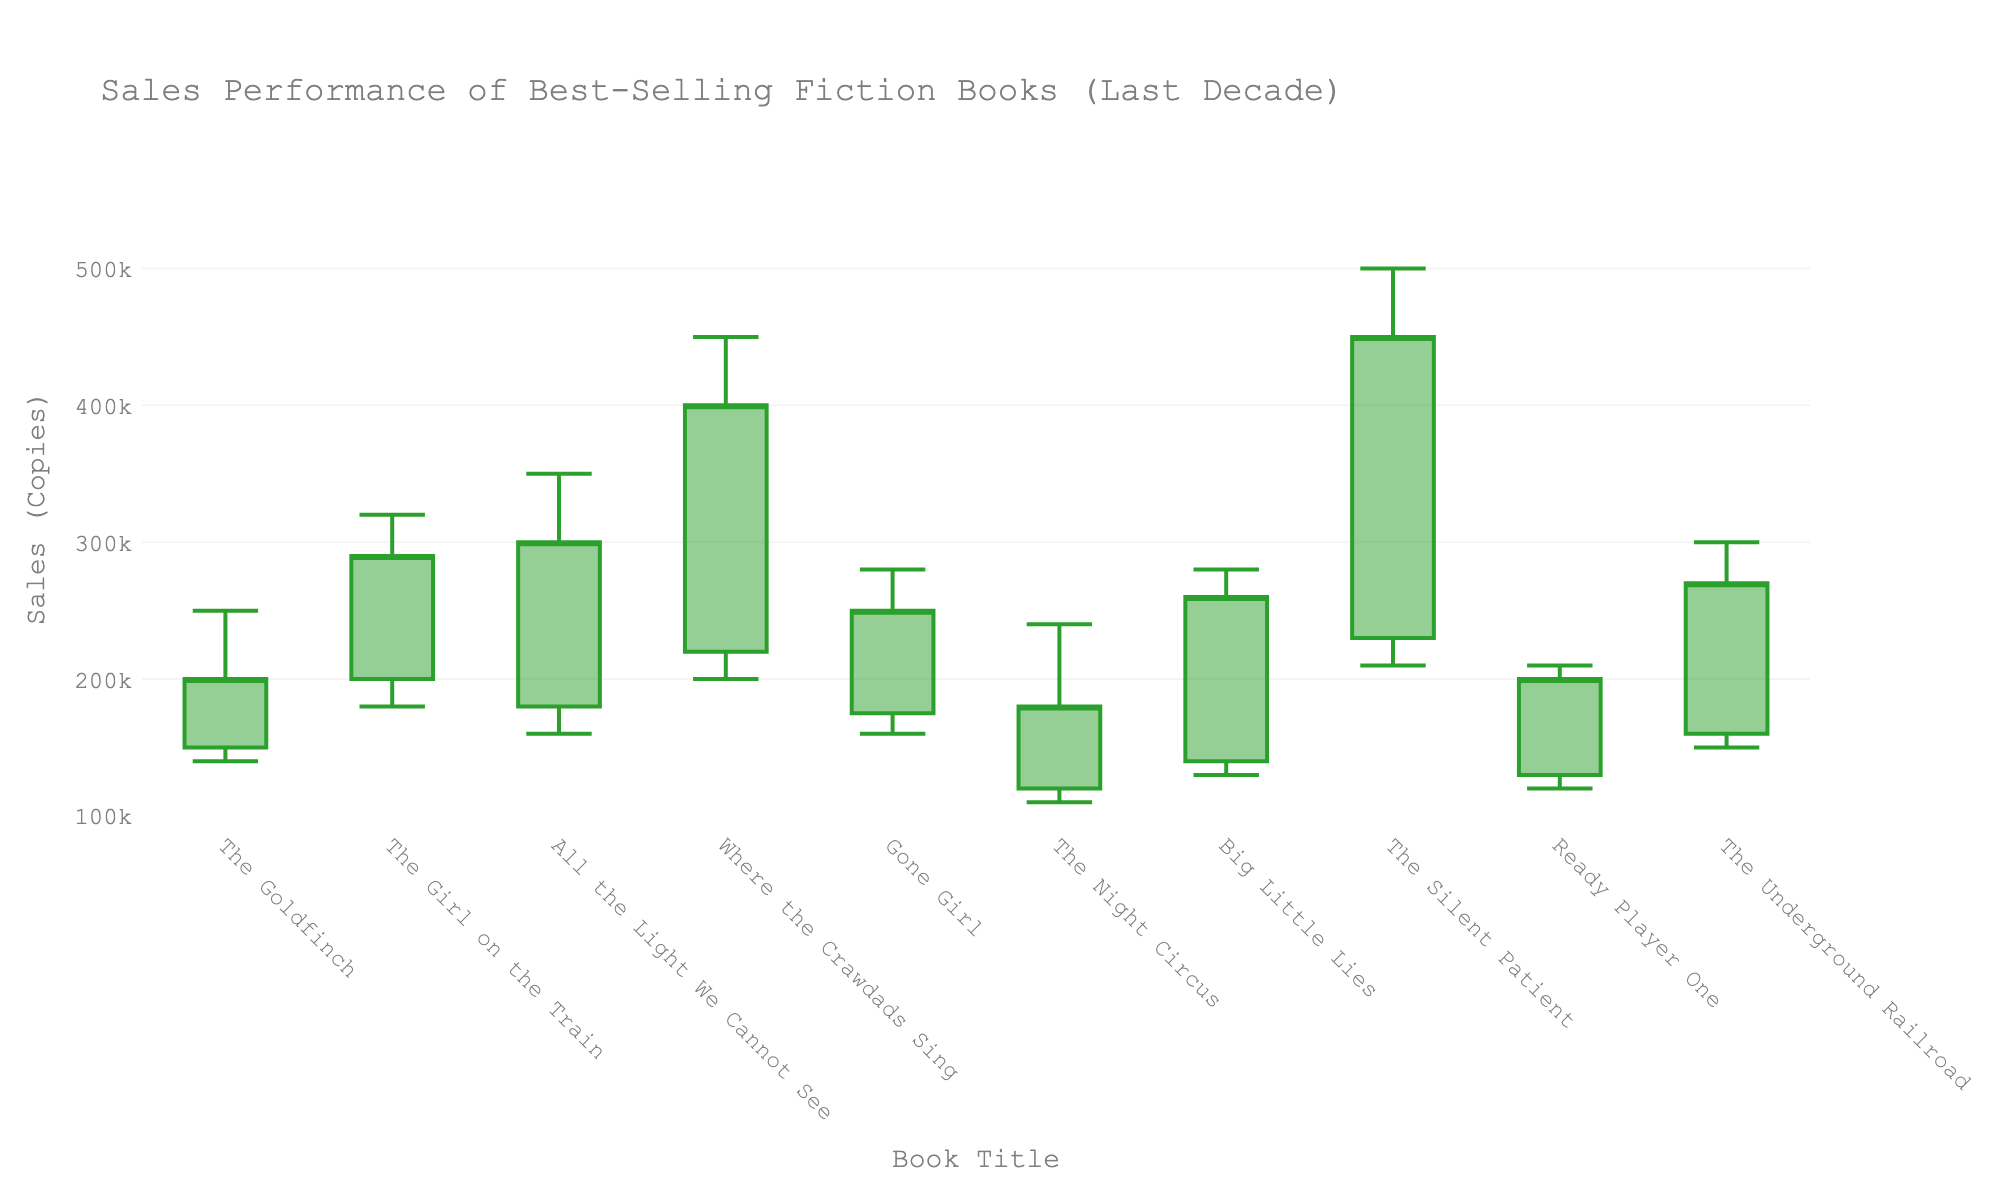What is the title of the chart? The title is typically placed at the top of the chart to describe what the chart represents. By looking at the top of the figure, we can see the chart's title.
Answer: Sales Performance of Best-Selling Fiction Books (Last Decade) Which book had the highest sales peak, and what was that peak? The peak sales are depicted by the highest point of the candlestick. By identifying which candlestick reaches the highest value on the y-axis, we can determine the book with the highest sales peak.
Answer: The Silent Patient, 500000 What was the lowest opening sales figure, and which book was it for? The opening sales figures are represented by the bottom edges of the candlesticks. By comparing the opening values, we can find the lowest one.
Answer: The Night Circus, 120000 Which books closed their sales higher than they opened? To find which books closed higher than they opened, we need to compare the close and open values for each book. If the close value is higher, then the book's sales closed higher.
Answer: The Goldfinch, The Girl on the Train, All the Light We Cannot See, Where the Crawdads Sing, The Silent Patient, Ready Player One, The Underground Railroad Which book had a higher closing sale, 'Gone Girl' or 'Big Little Lies'? We compare the closing sales values of 'Gone Girl' and 'Big Little Lies' by looking at the endpoints of their respective candlesticks.
Answer: Gone Girl What is the average closing sale of all the books? Add up all the closing sales values and divide by the number of books to calculate the average.
Answer: (200000 + 290000 + 300000 + 400000 + 250000 + 180000 + 260000 + 450000 + 200000 + 270000)/10 = 280000 Which year showed the largest range in sales figures, and what was that range? To identify the year with the largest range, we calculate the difference between the high and low sales figures for each book/year and find the maximum value.
Answer: The Silent Patient, 290000 How many books have their highest sales value greater than 300,000? We count the number of books where the 'High' value on the candlestick plot exceeds 300,000.
Answer: 5 What was the change in sales for 'The Underground Railroad' from open to close? Subtract the opening sales from the closing sales for 'The Underground Railroad'.
Answer: 270000 - 160000 = 110000 Which books have a red (decreasing) candlestick? A red candlestick indicates the closing sales were lower than the opening sales. Identify which books' close values are less than their open values.
Answer: Gone Girl, The Night Circus, Big Little Lies 